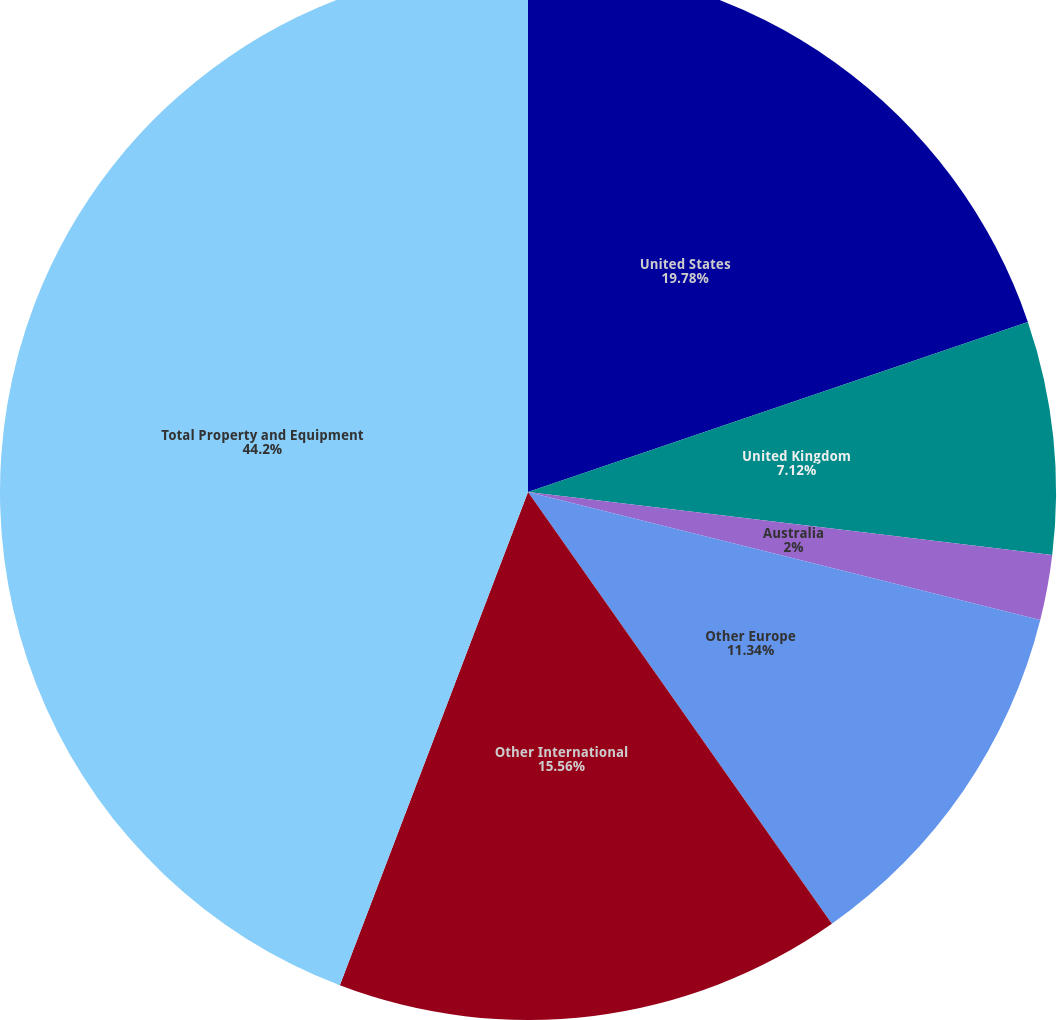<chart> <loc_0><loc_0><loc_500><loc_500><pie_chart><fcel>United States<fcel>United Kingdom<fcel>Australia<fcel>Other Europe<fcel>Other International<fcel>Total Property and Equipment<nl><fcel>19.78%<fcel>7.12%<fcel>2.0%<fcel>11.34%<fcel>15.56%<fcel>44.2%<nl></chart> 